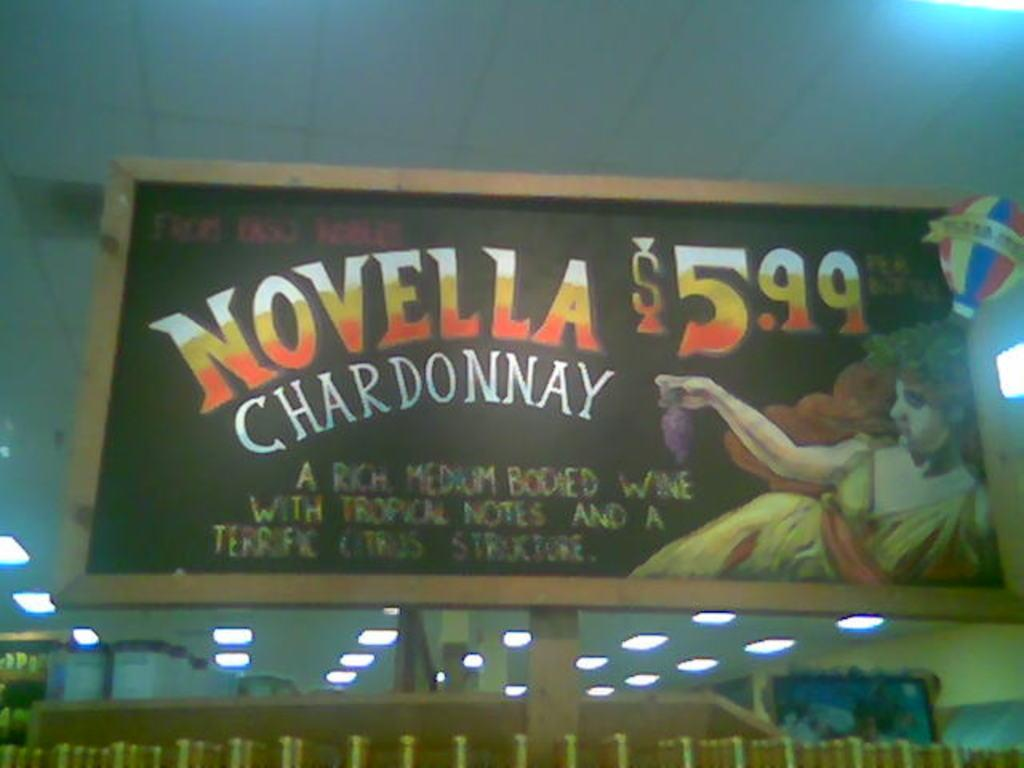<image>
Present a compact description of the photo's key features. A store chalkboard advertising Novella Chardonnay for only 5.99 